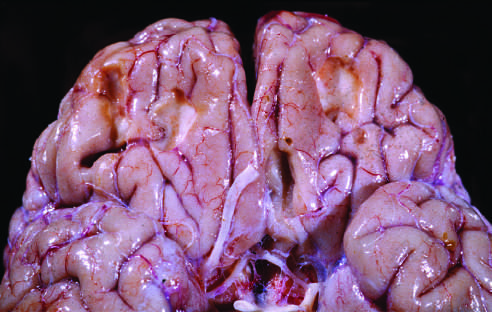what are present on the inferior frontal surface of this brain?
Answer the question using a single word or phrase. Remote contusions 